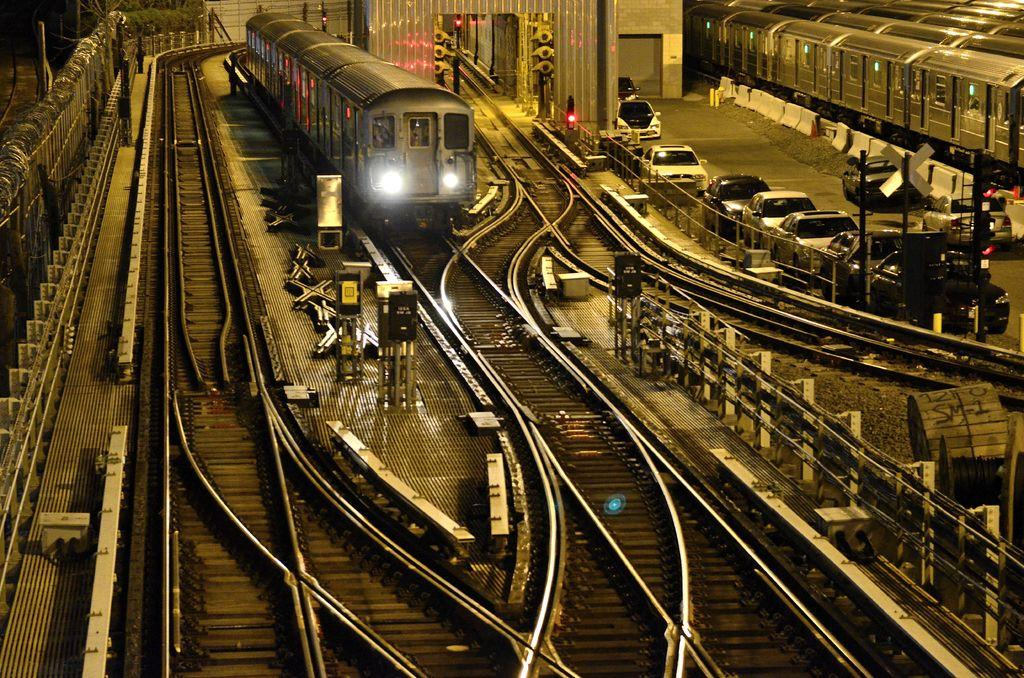What type of vehicle is in the image? There is an electric train in the image. What is the train traveling on? Railway tracks are present in the image. What other vehicles can be seen in the image? Cars are parked on the right side of the image. Are there any other trains visible in the image? Yes, trains are visible in the image. What is located on the left side of the image? Fencing is present on the left side of the image. Where is the kettle placed in the image? There is no kettle present in the image. What type of base does the electric train use to move in the image? The electric train moves on railway tracks, not a base. 